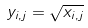Convert formula to latex. <formula><loc_0><loc_0><loc_500><loc_500>y _ { i , j } = \sqrt { x _ { i , j } }</formula> 